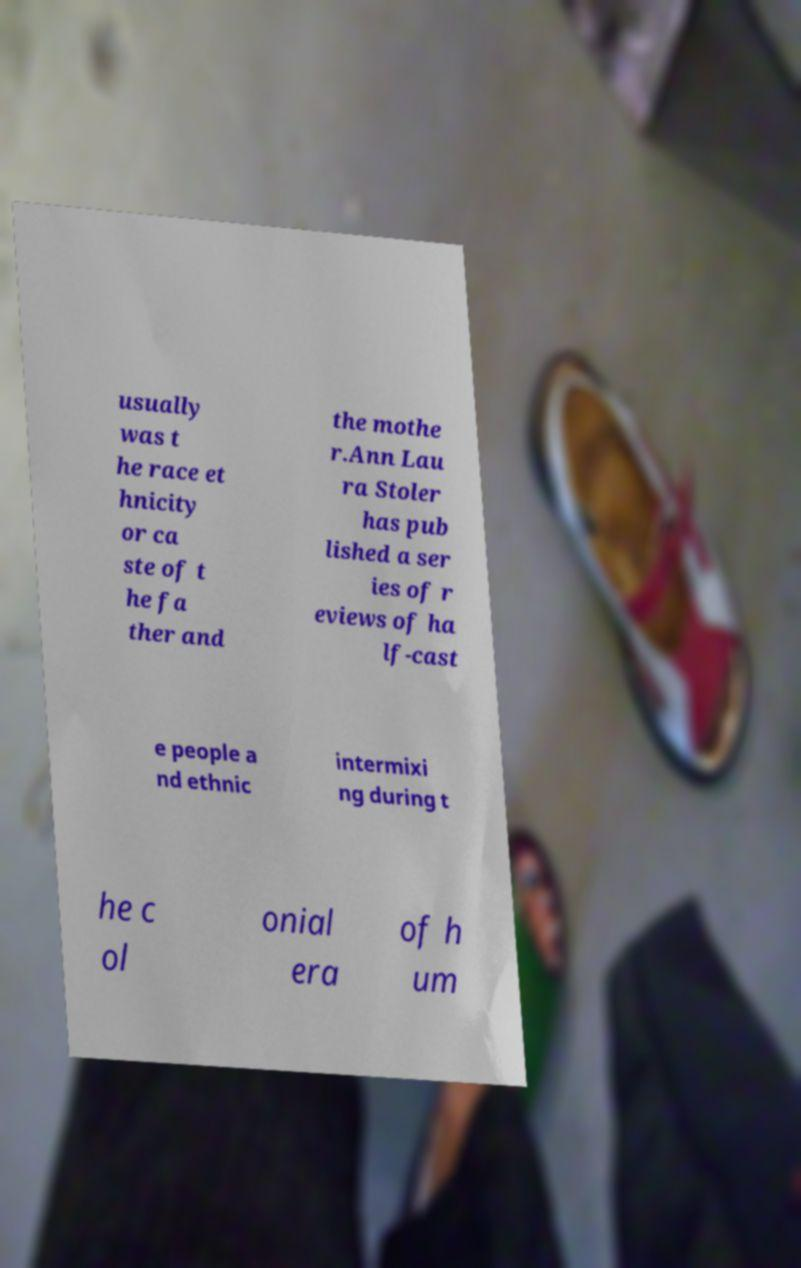Could you assist in decoding the text presented in this image and type it out clearly? usually was t he race et hnicity or ca ste of t he fa ther and the mothe r.Ann Lau ra Stoler has pub lished a ser ies of r eviews of ha lf-cast e people a nd ethnic intermixi ng during t he c ol onial era of h um 